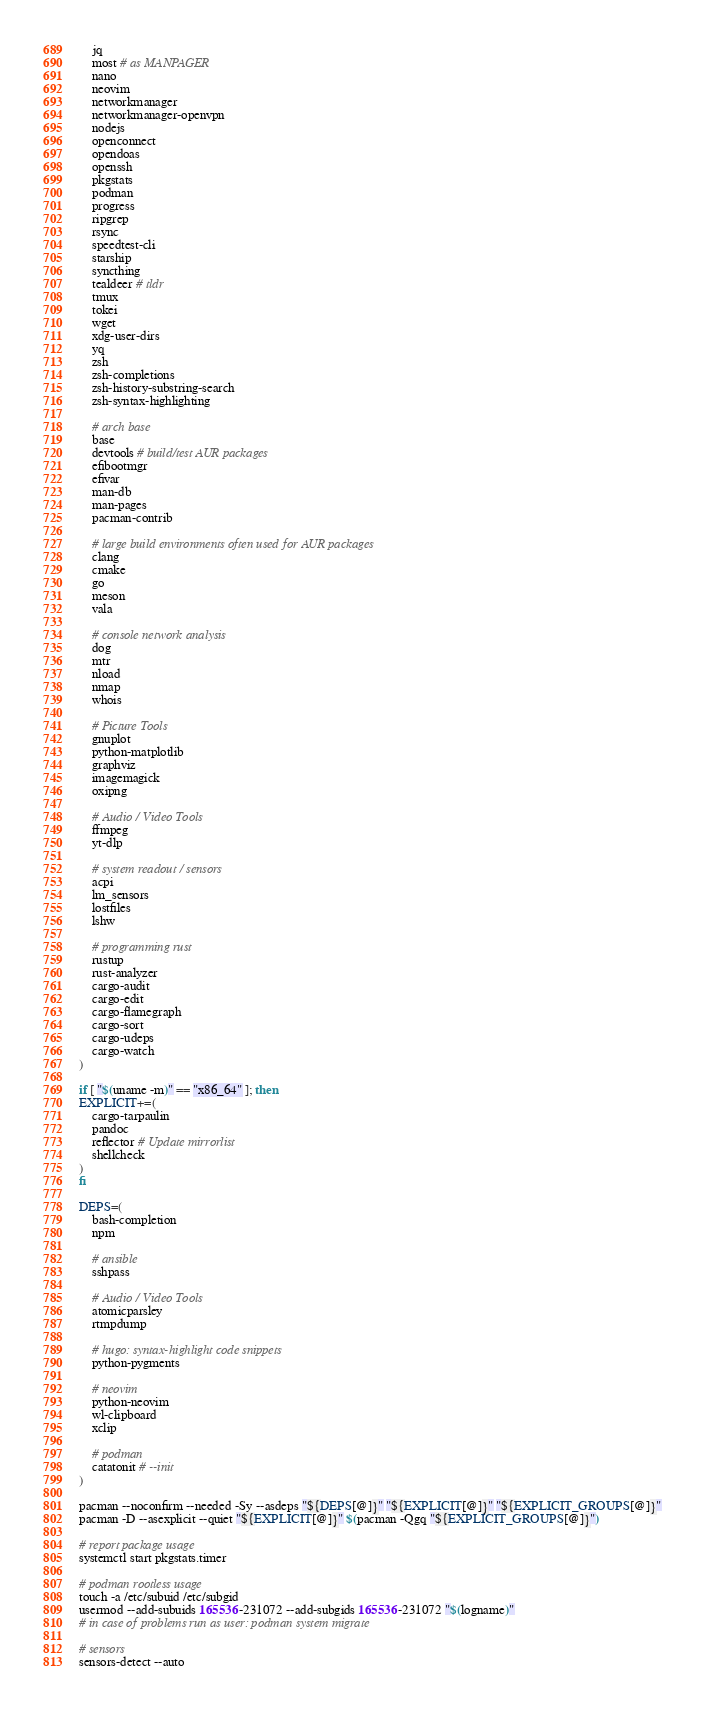Convert code to text. <code><loc_0><loc_0><loc_500><loc_500><_Bash_>	jq
	most # as MANPAGER
	nano
	neovim
	networkmanager
	networkmanager-openvpn
	nodejs
	openconnect
	opendoas
	openssh
	pkgstats
	podman
	progress
	ripgrep
	rsync
	speedtest-cli
	starship
	syncthing
	tealdeer # tldr
	tmux
	tokei
	wget
	xdg-user-dirs
	yq
	zsh
	zsh-completions
	zsh-history-substring-search
	zsh-syntax-highlighting

	# arch base
	base
	devtools # build/test AUR packages
	efibootmgr
	efivar
	man-db
	man-pages
	pacman-contrib

	# large build environments often used for AUR packages
	clang
	cmake
	go
	meson
	vala

	# console network analysis
	dog
	mtr
	nload
	nmap
	whois

	# Picture Tools
	gnuplot
	python-matplotlib
	graphviz
	imagemagick
	oxipng

	# Audio / Video Tools
	ffmpeg
	yt-dlp

	# system readout / sensors
	acpi
	lm_sensors
	lostfiles
	lshw

	# programming rust
	rustup
	rust-analyzer
	cargo-audit
	cargo-edit
	cargo-flamegraph
	cargo-sort
	cargo-udeps
	cargo-watch
)

if [ "$(uname -m)" == "x86_64" ]; then
EXPLICIT+=(
	cargo-tarpaulin
	pandoc
	reflector # Update mirrorlist
	shellcheck
)
fi

DEPS=(
	bash-completion
	npm

	# ansible
	sshpass

	# Audio / Video Tools
	atomicparsley
	rtmpdump

	# hugo: syntax-highlight code snippets
	python-pygments

	# neovim
	python-neovim
	wl-clipboard
	xclip

	# podman
	catatonit # --init
)

pacman --noconfirm --needed -Sy --asdeps "${DEPS[@]}" "${EXPLICIT[@]}" "${EXPLICIT_GROUPS[@]}"
pacman -D --asexplicit --quiet "${EXPLICIT[@]}" $(pacman -Qgq "${EXPLICIT_GROUPS[@]}")

# report package usage
systemctl start pkgstats.timer

# podman rootless usage
touch -a /etc/subuid /etc/subgid
usermod --add-subuids 165536-231072 --add-subgids 165536-231072 "$(logname)"
# in case of problems run as user: podman system migrate

# sensors
sensors-detect --auto
</code> 